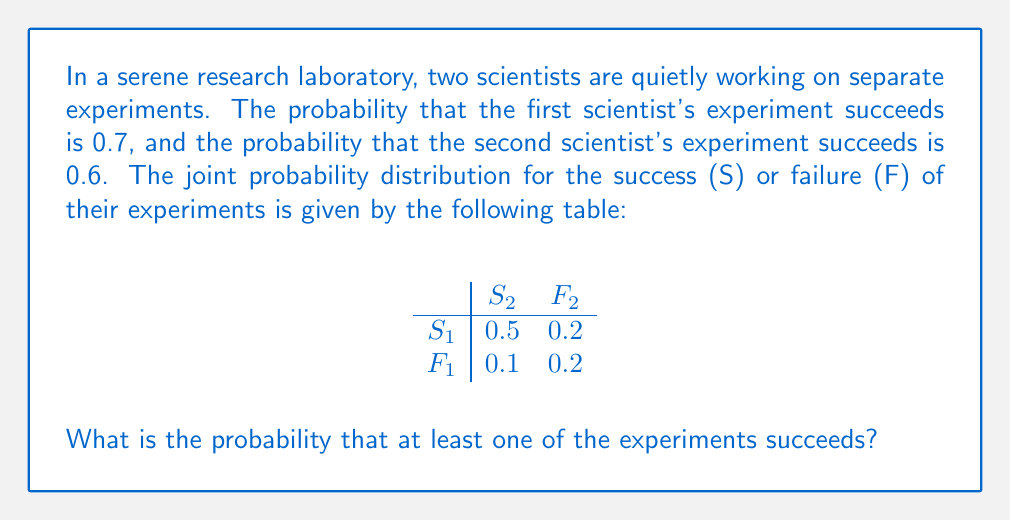Can you solve this math problem? Let's approach this problem step-by-step in a calm and focused manner:

1) First, we need to understand what the question is asking. We're looking for the probability that at least one experiment succeeds, which is equivalent to the probability that it's not the case that both experiments fail.

2) Let's define our events:
   $S_1$: First scientist's experiment succeeds
   $S_2$: Second scientist's experiment succeeds
   $F_1$: First scientist's experiment fails
   $F_2$: Second scientist's experiment fails

3) The probability we're looking for is:
   $P(\text{at least one succeeds}) = 1 - P(\text{both fail})$

4) From the joint probability distribution, we can see that:
   $P(F_1 \cap F_2) = 0.2$

5) Therefore:
   $P(\text{at least one succeeds}) = 1 - P(F_1 \cap F_2) = 1 - 0.2 = 0.8$

6) We can verify this result by summing the probabilities where at least one experiment succeeds:
   $P(S_1 \cap S_2) + P(S_1 \cap F_2) + P(F_1 \cap S_2) = 0.5 + 0.2 + 0.1 = 0.8$

This confirms our calculation.
Answer: The probability that at least one of the experiments succeeds is 0.8 or 80%. 